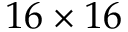<formula> <loc_0><loc_0><loc_500><loc_500>1 6 \times 1 6</formula> 